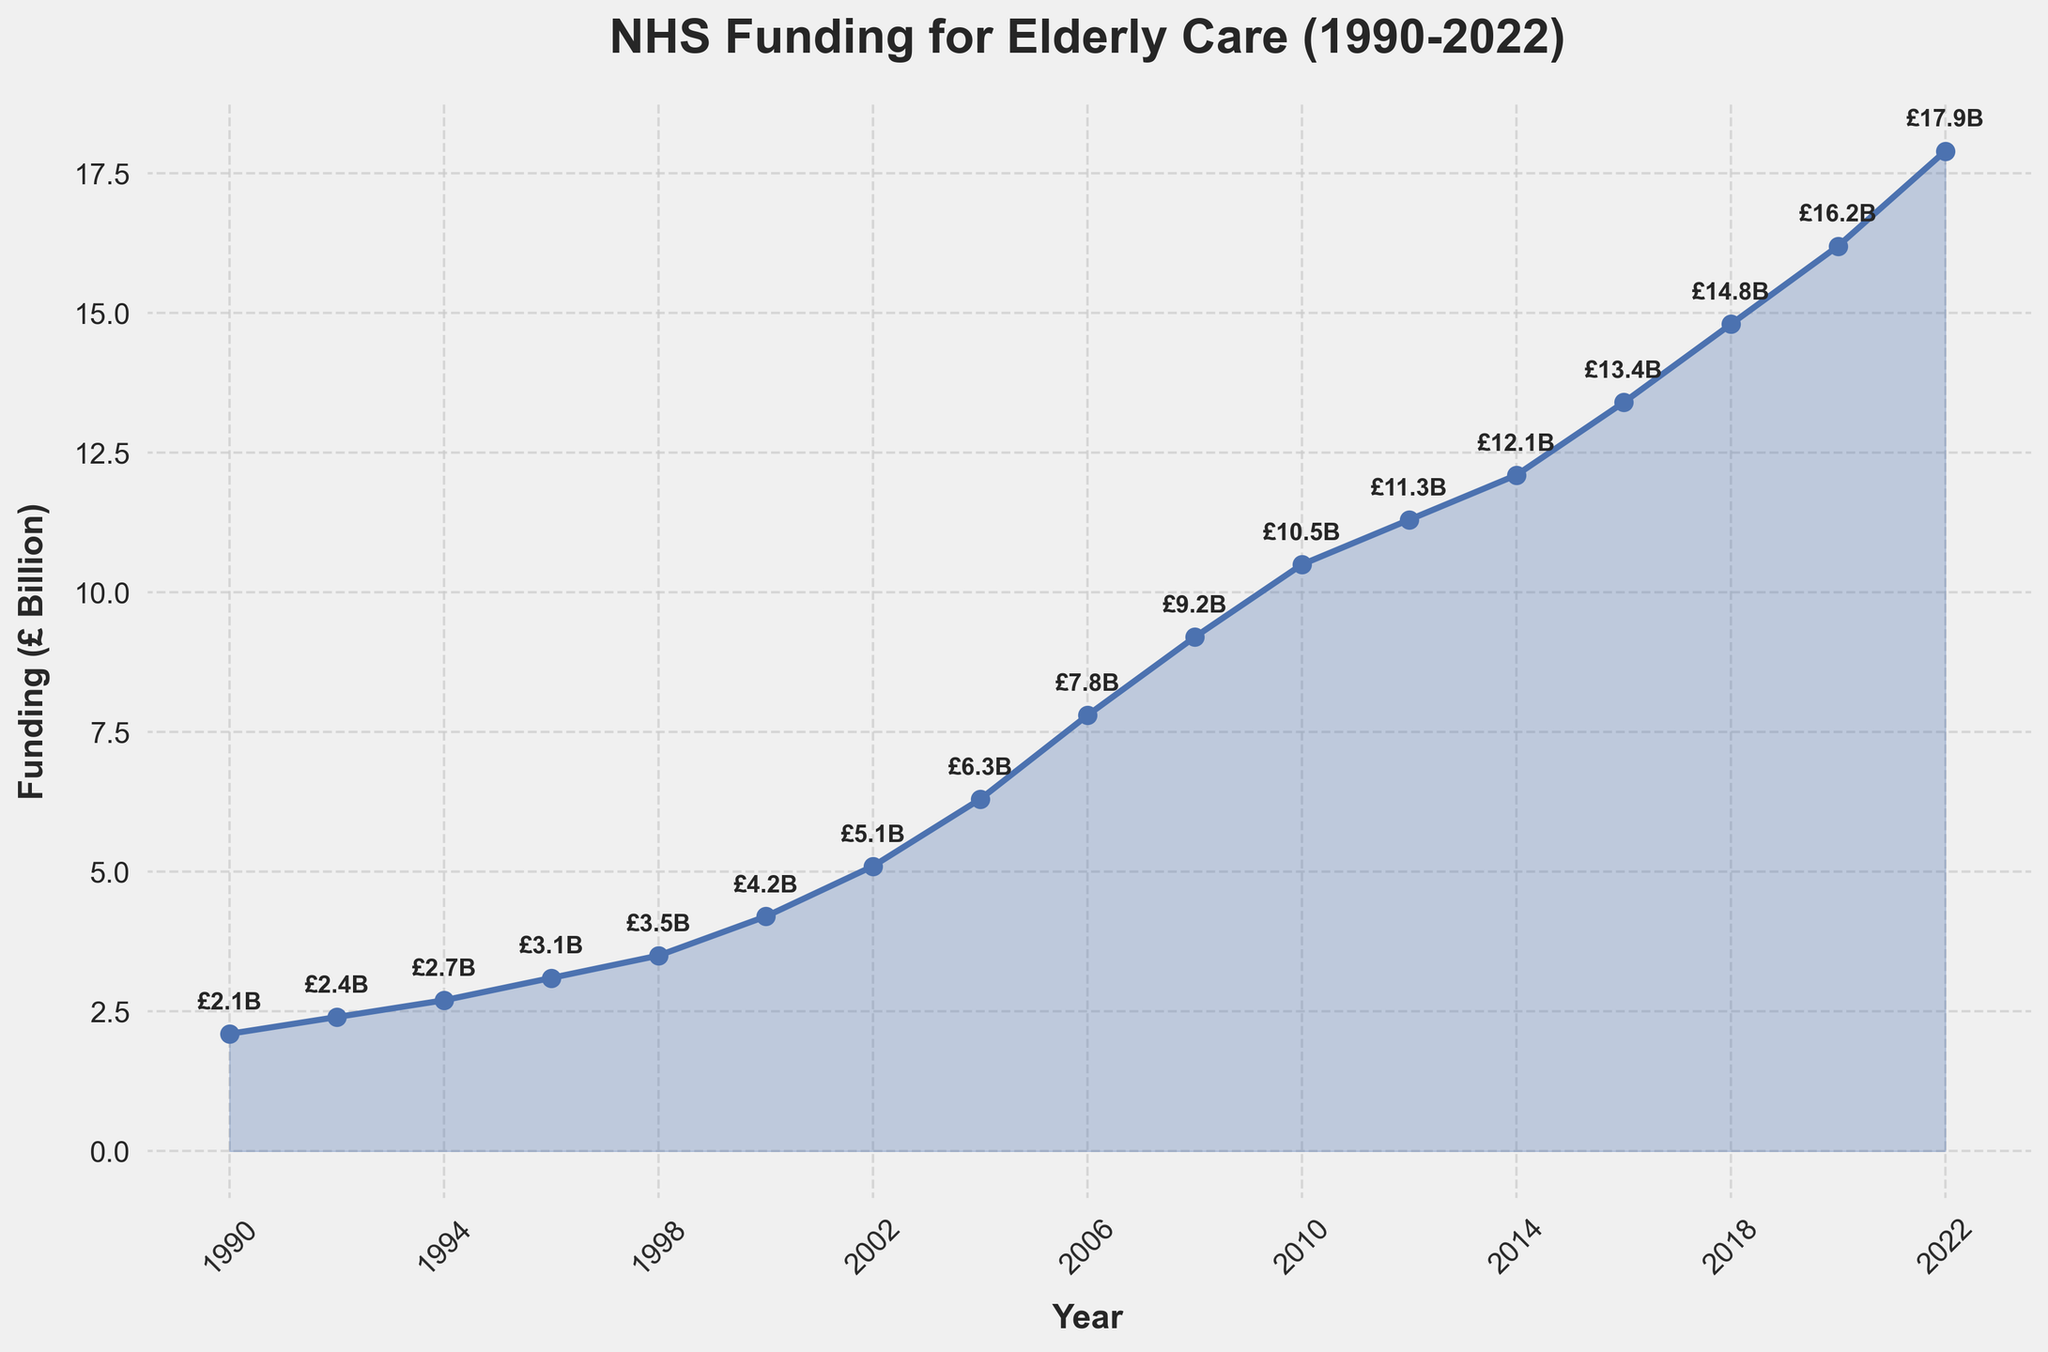What year did the NHS funding for elderly care first exceed £10 billion? The chart shows the trend of NHS funding over the years. Look for points where the funding exceeds £10 billion. The only jump over £10 billion happened in 2010.
Answer: 2010 Compare the NHS funding for elderly care in 1990 and 2022. How much more is it in 2022? Find the funding values for the years 1990 (£2.1 billion) and 2022 (£17.9 billion) on the chart. Subtract the earlier figure from the later one: £17.9 billion - £2.1 billion.
Answer: £15.8 billion What was the funding for elderly care in 2018, and how did it compare to 2020? Locate the points for the years 2018 and 2020, which are £14.8 billion and £16.2 billion respectively. Compare these amounts by calculating the difference: £16.2 billion - £14.8 billion.
Answer: £1.4 billion higher in 2020 Between which two consecutive data points did the NHS funding grow the most? Observe the steepest segments along the plotted line. Significant jumps can be seen especially between 2000 and 2002, and 2006 and 2008. Comparing precise values: £4.2 billion (2000) to £5.1 billion (2002) is £0.9 billion, while £7.8 billion (2006) to £9.2 billion (2008) is £1.4 billion.
Answer: Between 2006 and 2008 How has the trend of NHS funding for elderly care changed from 1990 to 2022? Describe the general uptrend visible in the chart, noticing that funding consistently increased from £2.1 billion in 1990 to £17.9 billion in 2022 without any major declines.
Answer: Steadily increased What is the average NHS funding for elderly care from 1990 to 2022? Sum all the funding values (£2.1 + £2.4 + £2.7 + £3.1 + £3.5 + £4.2 + £5.1 + £6.3 + £7.8 + £9.2 + £10.5 + £11.3 + £12.1 + £13.4 + £14.8 + £16.2 + £17.9) and divide by the number of years (17).
Answer: Around £8.73 billion Through which years did the NHS funding show the least growth? Identify the flattest segments of the line plot. The funding between 2010 (£10.5 billion) to 2012 (£11.3 billion) typically shows lesser increments compared to other periods, which makes it flatter.
Answer: Between 2010 and 2012 What visual elements indicate the rising trend in the NHS funding for elderly care? Note the continuous upward slope of the line, the positive incline, and the filled area under the line increasing from left to right which indicates rising values over the years.
Answer: Upward-sloping line What was the NHS funding in 2000, and how much did it increase by 2004? Identify the value for the year 2000, which is £4.2 billion, and for 2004, which is £6.3 billion. Subtract the 2000 value from the 2004 value: £6.3 billion - £4.2 billion.
Answer: £2.1 billion increase 